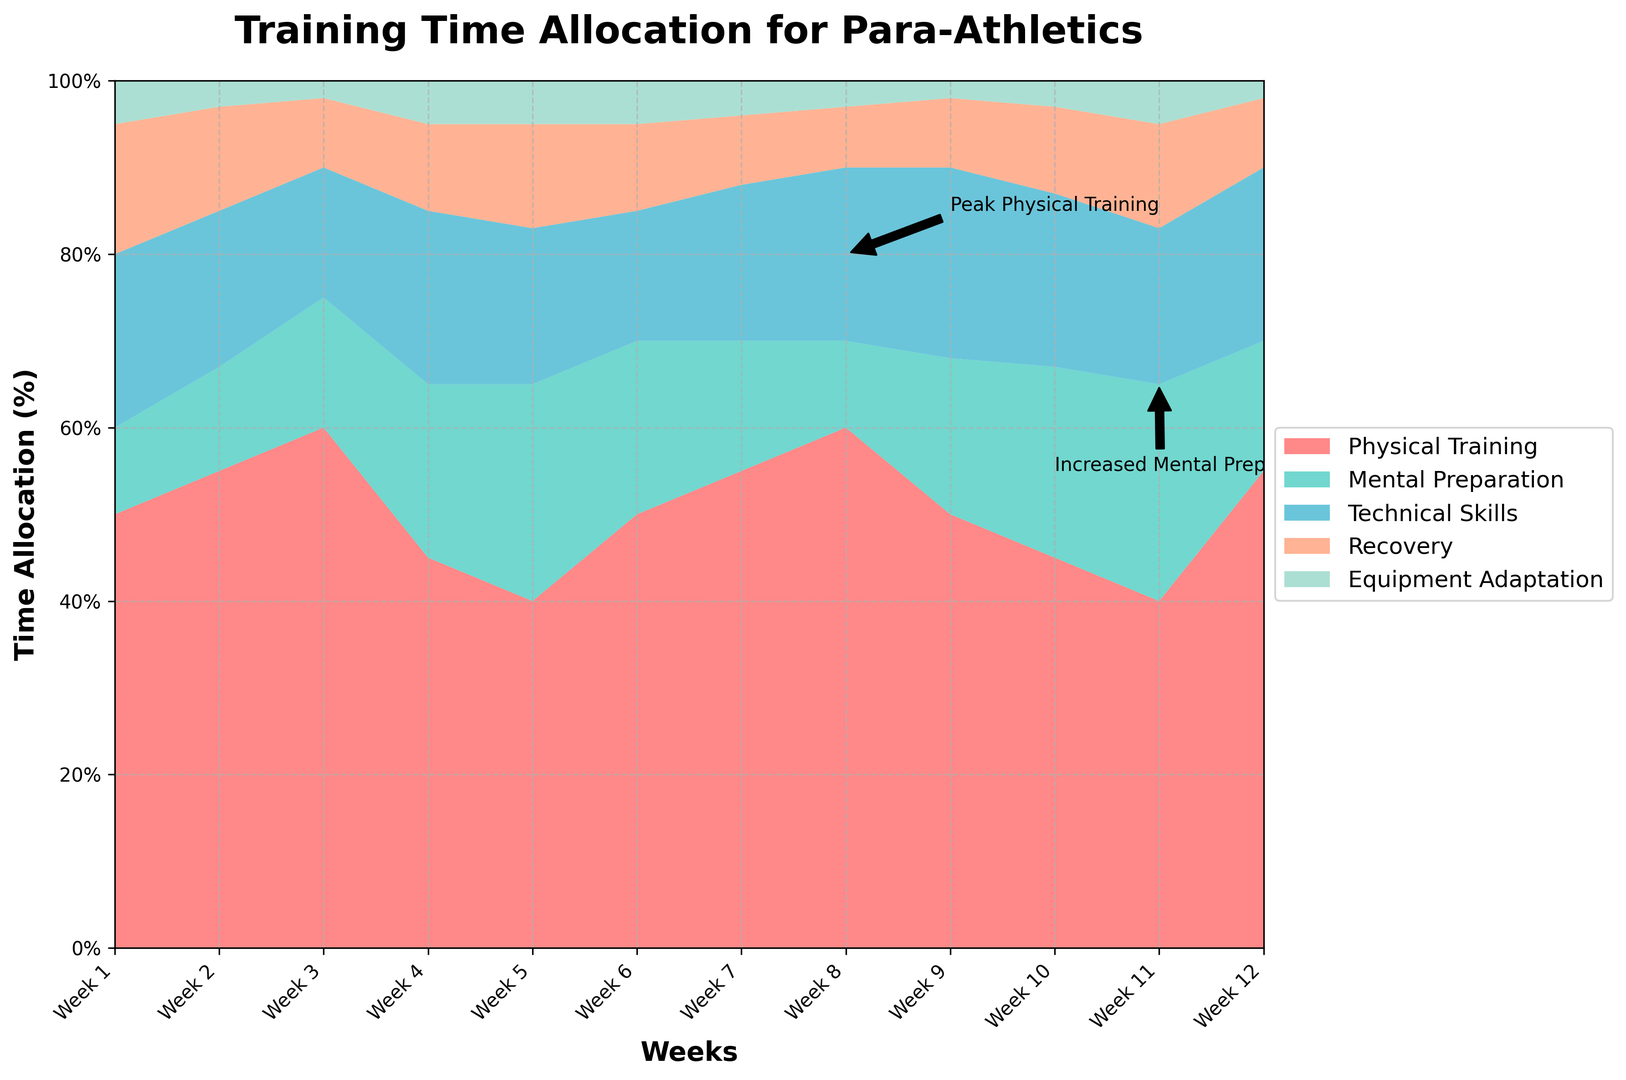What is the average time allocated to "Physical Training" over the 12 weeks? To find the average, add the values for "Physical Training" across all weeks and divide by the number of weeks. (50 + 55 + 60 + 45 + 40 + 50 + 55 + 60 + 50 + 45 + 40 + 55) / 12 = 55
Answer: 55 Which week shows the highest allocation for "Mental Preparation"? By examining the heights of the sections of the area corresponding to "Mental Preparation," we see that the highest occurs in Week 11 at 25%.
Answer: Week 11 Compare the allocation of "Recovery" in Week 3 and Week 5. Which one is higher and by how much? In Week 3, "Recovery" is allocated 8%, and in Week 5, it's 12%. To compare, subtract the smaller value from the larger one. 12% - 8% = 4%
Answer: Week 5, by 4% Identify the week with the least focus on "Equipment Adaptation" and its value. By checking the areas for "Equipment Adaptation," the lowest value is in Week 3 with 2%.
Answer: Week 3, 2% How does the allocation for "Technical Skills" change from Week 1 to Week 9? In Week 1, the allocation is 20%; by Week 9, it increases to 22%. The difference is 22% - 20% = 2%.
Answer: Increases by 2% What is the total allocation for "Recovery" and "Technical Skills" combined in Week 7? "Recovery" is 8% and "Technical Skills" is 18% in Week 7. Adding these gives 8% + 18% = 26%.
Answer: 26% During which week is the cumulative allocation for "Recovery" and "Mental Preparation" exactly equal to or higher than 30%? Checking each week, in Week 10, "Recovery" is 10% and "Mental Preparation" is 22%. Their sum is 10% + 22% = 32%, which is above 30%.
Answer: Week 10 At which week does "Physical Training" and "Mental Preparation" combined peak and what is the peak value? Peak value is seen in Week 8. The combined "Physical Training" is 60% and "Mental Preparation" is 10%; summing up gives 60% + 10% = 70%.
Answer: Week 8, 70% During which week does "Technical Skills" have the exact highest percentage? "Technical Skills" reaches 22% in Week 9, its highest percentage across all weeks.
Answer: Week 9 